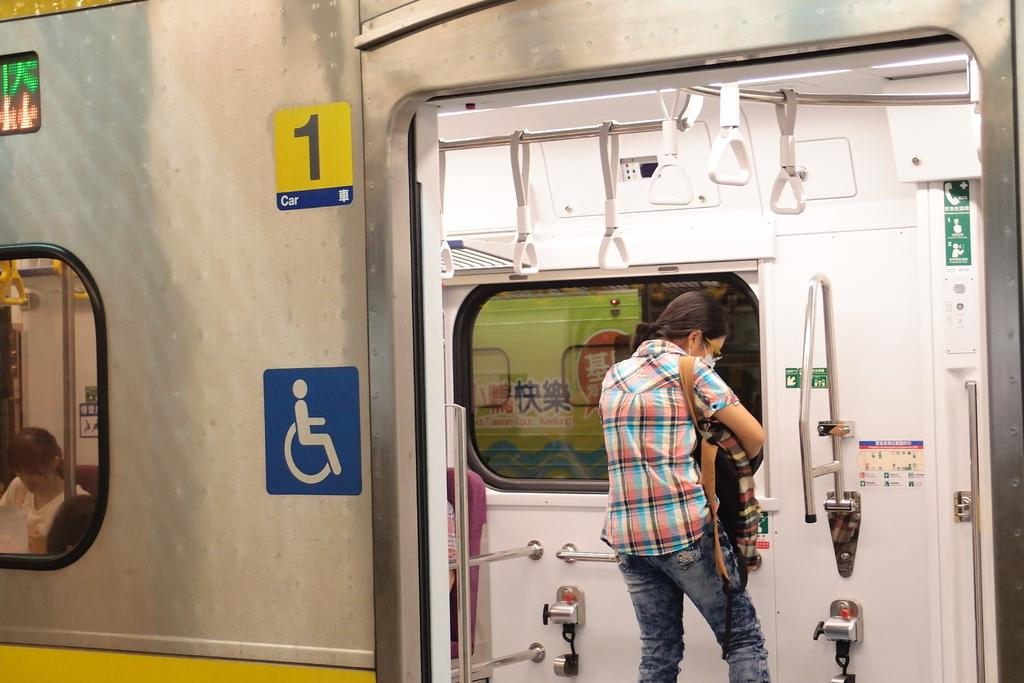Who is present in the image? There is a person in the image. Where is the person located? The person is in a train. What can be found inside the train? There are holders and stands in the train. What is the person carrying on their back? The person is wearing a backpack. What type of grass can be seen growing on the person's head in the image? There is no grass present in the image, and the person's head is not mentioned as having any vegetation. 